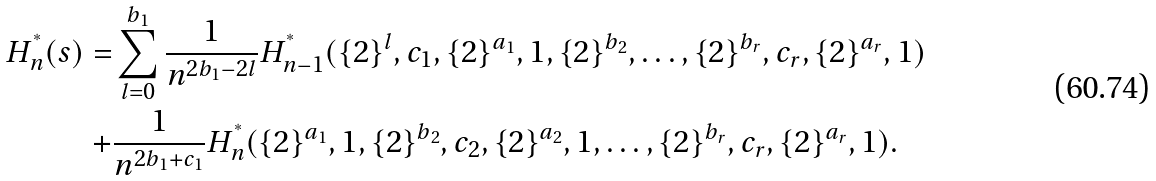<formula> <loc_0><loc_0><loc_500><loc_500>H ^ { ^ { * } } _ { n } ( s ) = & \sum _ { l = 0 } ^ { b _ { 1 } } \frac { 1 } { n ^ { 2 b _ { 1 } - 2 l } } H ^ { ^ { * } } _ { n - 1 } ( \{ 2 \} ^ { l } , c _ { 1 } , \{ 2 \} ^ { a _ { 1 } } , 1 , \{ 2 \} ^ { b _ { 2 } } , \dots , \{ 2 \} ^ { b _ { r } } , c _ { r } , \{ 2 \} ^ { a _ { r } } , 1 ) \\ + & \frac { 1 } { n ^ { 2 b _ { 1 } + c _ { 1 } } } H ^ { ^ { * } } _ { n } ( \{ 2 \} ^ { a _ { 1 } } , 1 , \{ 2 \} ^ { b _ { 2 } } , c _ { 2 } , \{ 2 \} ^ { a _ { 2 } } , 1 , \dots , \{ 2 \} ^ { b _ { r } } , c _ { r } , \{ 2 \} ^ { a _ { r } } , 1 ) .</formula> 